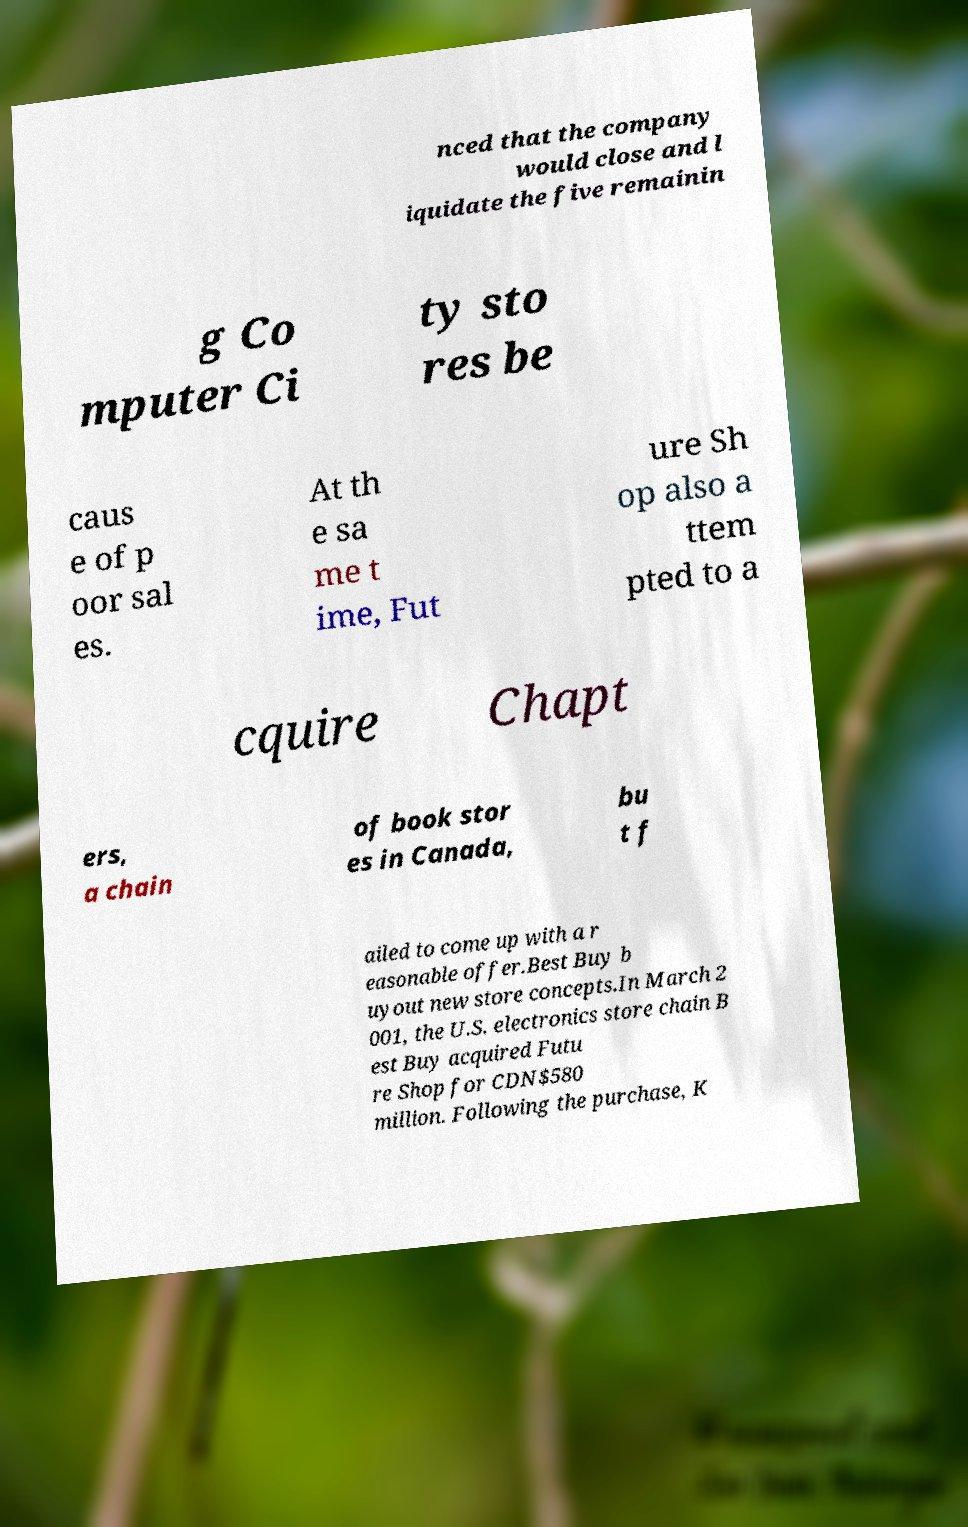Can you accurately transcribe the text from the provided image for me? nced that the company would close and l iquidate the five remainin g Co mputer Ci ty sto res be caus e of p oor sal es. At th e sa me t ime, Fut ure Sh op also a ttem pted to a cquire Chapt ers, a chain of book stor es in Canada, bu t f ailed to come up with a r easonable offer.Best Buy b uyout new store concepts.In March 2 001, the U.S. electronics store chain B est Buy acquired Futu re Shop for CDN$580 million. Following the purchase, K 